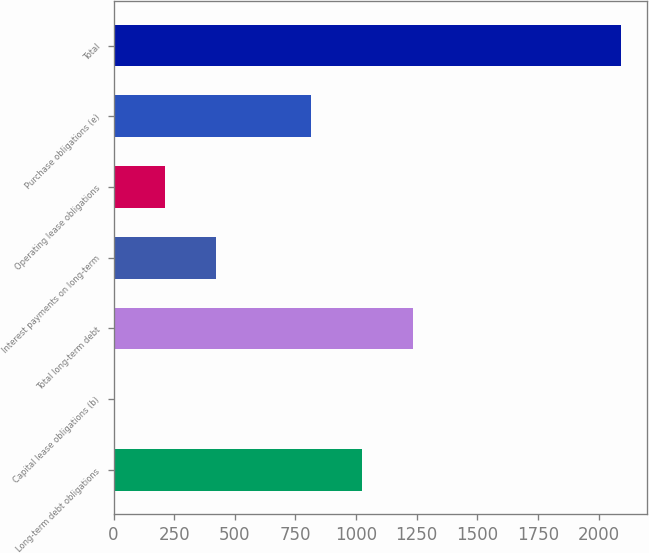<chart> <loc_0><loc_0><loc_500><loc_500><bar_chart><fcel>Long-term debt obligations<fcel>Capital lease obligations (b)<fcel>Total long-term debt<fcel>Interest payments on long-term<fcel>Operating lease obligations<fcel>Purchase obligations (e)<fcel>Total<nl><fcel>1023.79<fcel>3.6<fcel>1232.88<fcel>421.78<fcel>212.69<fcel>814.7<fcel>2094.5<nl></chart> 